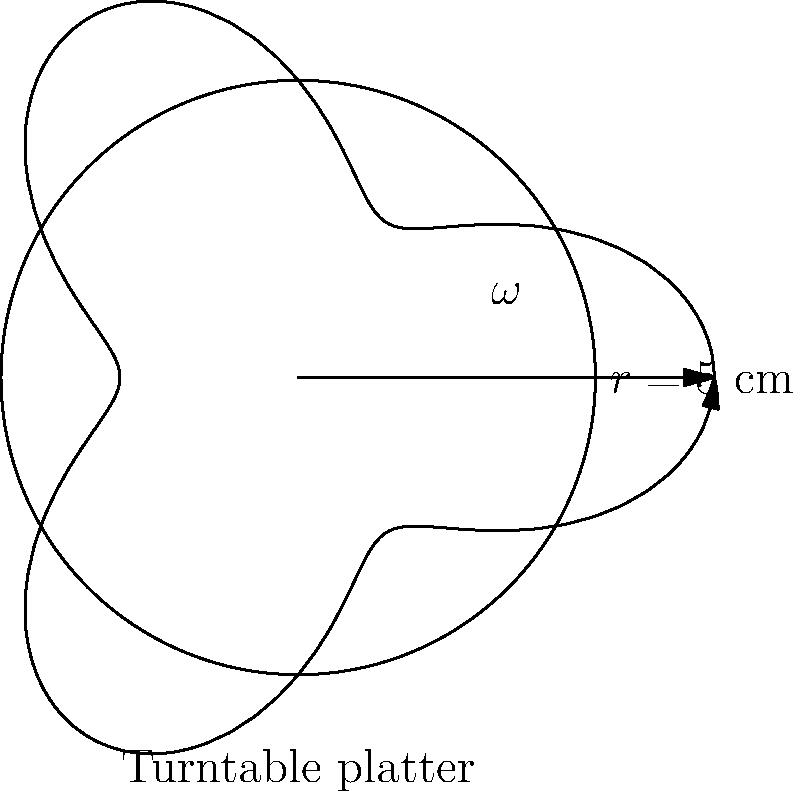A vinyl enthusiast's turntable platter has a radius of 5 cm. The angular velocity of the platter is described by the polar function $r = 5 + 2\cos(3\theta)$ cm, where $\theta$ is in radians. What is the maximum angular velocity of the platter in radians per second? To find the maximum angular velocity, we need to follow these steps:

1) The angular velocity $\omega$ is given by the formula:
   $$\omega = \frac{d\theta}{dt}$$

2) In polar coordinates, we have:
   $$r = 5 + 2\cos(3\theta)$$

3) To find $\frac{d\theta}{dt}$, we need to use the equation:
   $$\frac{dr}{dt} = \frac{\partial r}{\partial \theta} \cdot \frac{d\theta}{dt}$$

4) Calculate $\frac{\partial r}{\partial \theta}$:
   $$\frac{\partial r}{\partial \theta} = -6\sin(3\theta)$$

5) Rearrange the equation to isolate $\frac{d\theta}{dt}$:
   $$\frac{d\theta}{dt} = \frac{\frac{dr}{dt}}{-6\sin(3\theta)}$$

6) The maximum angular velocity occurs when $\sin(3\theta) = -1$, which maximizes the denominator.

7) At this point, $\frac{dr}{dt} = 2$ cm/s (the amplitude of the cosine function).

8) Therefore, the maximum angular velocity is:
   $$\omega_{max} = \frac{2}{6} = \frac{1}{3}$$ radians per second.
Answer: $\frac{1}{3}$ rad/s 